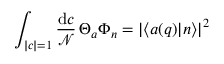Convert formula to latex. <formula><loc_0><loc_0><loc_500><loc_500>\int _ { | c | = 1 } { \frac { d c } { \mathcal { N } } } \, \Theta _ { a } \Phi _ { n } = | \langle a ( q ) | n \rangle | ^ { 2 }</formula> 